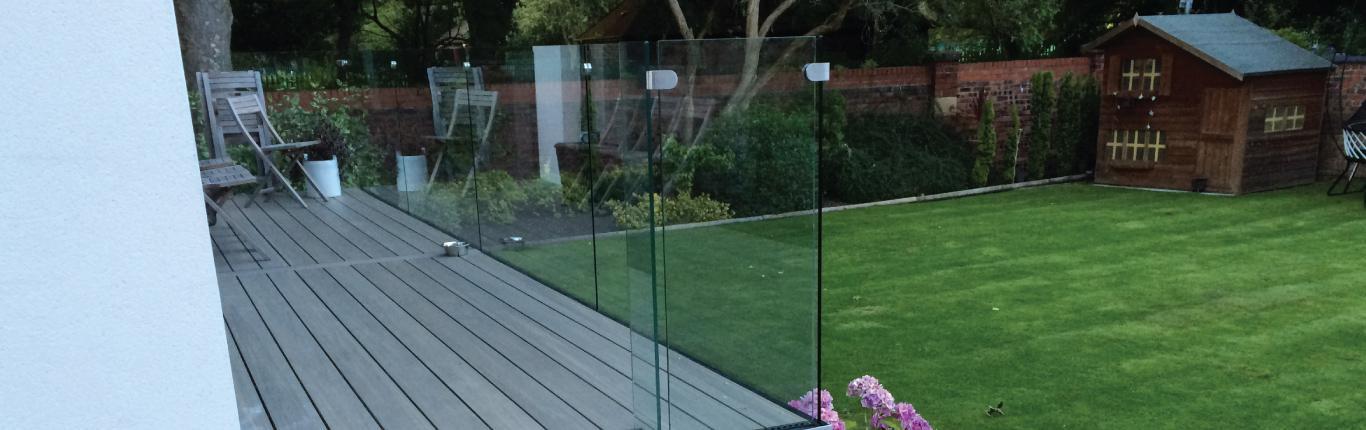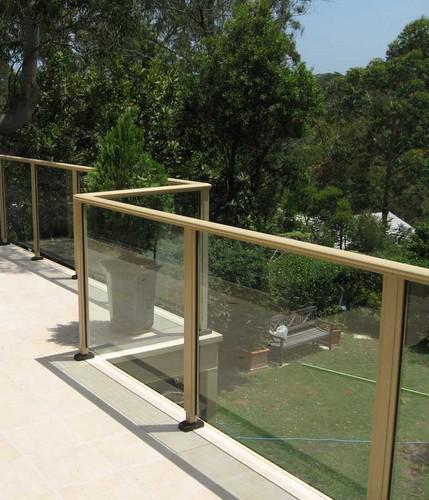The first image is the image on the left, the second image is the image on the right. Assess this claim about the two images: "There are two chairs and one wooden slotted table on a patio that is enclosed  with glass panels.". Correct or not? Answer yes or no. No. The first image is the image on the left, the second image is the image on the right. Given the left and right images, does the statement "In each image, a glass-paneled balcony overlooks an area of green grass, and one of the balconies pictured has a top rail on the glass panels but the other does not." hold true? Answer yes or no. Yes. 